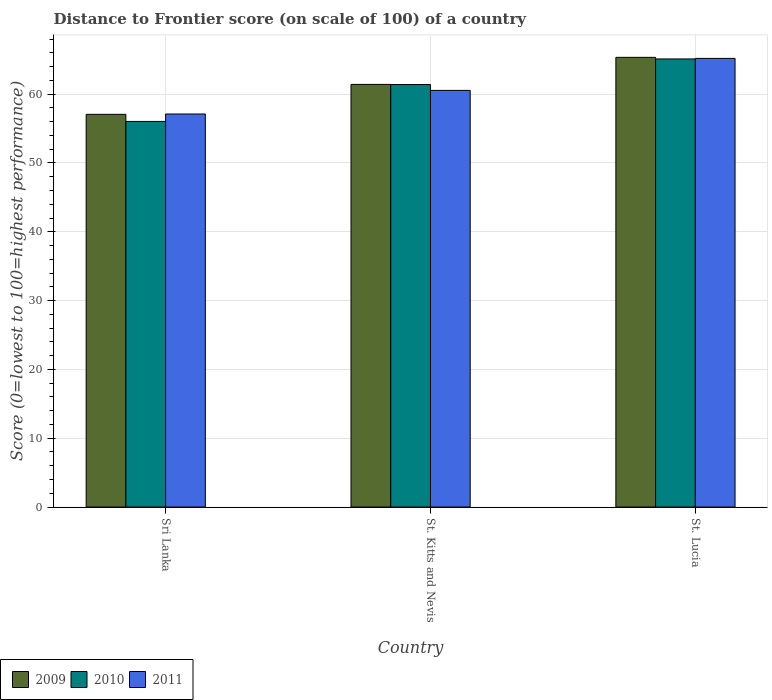How many groups of bars are there?
Provide a succinct answer. 3. Are the number of bars per tick equal to the number of legend labels?
Make the answer very short. Yes. Are the number of bars on each tick of the X-axis equal?
Offer a very short reply. Yes. How many bars are there on the 1st tick from the left?
Provide a short and direct response. 3. What is the label of the 1st group of bars from the left?
Your answer should be compact. Sri Lanka. In how many cases, is the number of bars for a given country not equal to the number of legend labels?
Offer a terse response. 0. What is the distance to frontier score of in 2011 in Sri Lanka?
Ensure brevity in your answer.  57.12. Across all countries, what is the maximum distance to frontier score of in 2011?
Offer a very short reply. 65.2. Across all countries, what is the minimum distance to frontier score of in 2011?
Provide a short and direct response. 57.12. In which country was the distance to frontier score of in 2009 maximum?
Your response must be concise. St. Lucia. In which country was the distance to frontier score of in 2009 minimum?
Offer a terse response. Sri Lanka. What is the total distance to frontier score of in 2010 in the graph?
Make the answer very short. 182.56. What is the difference between the distance to frontier score of in 2009 in Sri Lanka and that in St. Kitts and Nevis?
Your answer should be very brief. -4.35. What is the difference between the distance to frontier score of in 2010 in Sri Lanka and the distance to frontier score of in 2009 in St. Lucia?
Your answer should be very brief. -9.31. What is the average distance to frontier score of in 2010 per country?
Provide a short and direct response. 60.85. What is the difference between the distance to frontier score of of/in 2009 and distance to frontier score of of/in 2011 in St. Lucia?
Provide a short and direct response. 0.15. In how many countries, is the distance to frontier score of in 2011 greater than 32?
Give a very brief answer. 3. What is the ratio of the distance to frontier score of in 2010 in Sri Lanka to that in St. Kitts and Nevis?
Give a very brief answer. 0.91. Is the difference between the distance to frontier score of in 2009 in Sri Lanka and St. Lucia greater than the difference between the distance to frontier score of in 2011 in Sri Lanka and St. Lucia?
Keep it short and to the point. No. What is the difference between the highest and the second highest distance to frontier score of in 2011?
Provide a short and direct response. 4.65. What is the difference between the highest and the lowest distance to frontier score of in 2011?
Offer a terse response. 8.08. In how many countries, is the distance to frontier score of in 2010 greater than the average distance to frontier score of in 2010 taken over all countries?
Your response must be concise. 2. What does the 1st bar from the left in Sri Lanka represents?
Give a very brief answer. 2009. Is it the case that in every country, the sum of the distance to frontier score of in 2010 and distance to frontier score of in 2009 is greater than the distance to frontier score of in 2011?
Offer a terse response. Yes. Are all the bars in the graph horizontal?
Provide a succinct answer. No. What is the difference between two consecutive major ticks on the Y-axis?
Ensure brevity in your answer.  10. Does the graph contain any zero values?
Ensure brevity in your answer.  No. Does the graph contain grids?
Make the answer very short. Yes. Where does the legend appear in the graph?
Provide a succinct answer. Bottom left. How are the legend labels stacked?
Your answer should be compact. Horizontal. What is the title of the graph?
Ensure brevity in your answer.  Distance to Frontier score (on scale of 100) of a country. Does "2000" appear as one of the legend labels in the graph?
Your answer should be compact. No. What is the label or title of the X-axis?
Give a very brief answer. Country. What is the label or title of the Y-axis?
Offer a very short reply. Score (0=lowest to 100=highest performance). What is the Score (0=lowest to 100=highest performance) of 2009 in Sri Lanka?
Offer a very short reply. 57.07. What is the Score (0=lowest to 100=highest performance) of 2010 in Sri Lanka?
Keep it short and to the point. 56.04. What is the Score (0=lowest to 100=highest performance) of 2011 in Sri Lanka?
Provide a short and direct response. 57.12. What is the Score (0=lowest to 100=highest performance) of 2009 in St. Kitts and Nevis?
Your answer should be very brief. 61.42. What is the Score (0=lowest to 100=highest performance) of 2010 in St. Kitts and Nevis?
Offer a terse response. 61.4. What is the Score (0=lowest to 100=highest performance) in 2011 in St. Kitts and Nevis?
Provide a short and direct response. 60.55. What is the Score (0=lowest to 100=highest performance) of 2009 in St. Lucia?
Offer a terse response. 65.35. What is the Score (0=lowest to 100=highest performance) in 2010 in St. Lucia?
Give a very brief answer. 65.12. What is the Score (0=lowest to 100=highest performance) in 2011 in St. Lucia?
Give a very brief answer. 65.2. Across all countries, what is the maximum Score (0=lowest to 100=highest performance) in 2009?
Provide a succinct answer. 65.35. Across all countries, what is the maximum Score (0=lowest to 100=highest performance) in 2010?
Your answer should be compact. 65.12. Across all countries, what is the maximum Score (0=lowest to 100=highest performance) in 2011?
Your answer should be very brief. 65.2. Across all countries, what is the minimum Score (0=lowest to 100=highest performance) in 2009?
Ensure brevity in your answer.  57.07. Across all countries, what is the minimum Score (0=lowest to 100=highest performance) in 2010?
Make the answer very short. 56.04. Across all countries, what is the minimum Score (0=lowest to 100=highest performance) of 2011?
Offer a very short reply. 57.12. What is the total Score (0=lowest to 100=highest performance) of 2009 in the graph?
Make the answer very short. 183.84. What is the total Score (0=lowest to 100=highest performance) in 2010 in the graph?
Give a very brief answer. 182.56. What is the total Score (0=lowest to 100=highest performance) in 2011 in the graph?
Your response must be concise. 182.87. What is the difference between the Score (0=lowest to 100=highest performance) of 2009 in Sri Lanka and that in St. Kitts and Nevis?
Ensure brevity in your answer.  -4.35. What is the difference between the Score (0=lowest to 100=highest performance) in 2010 in Sri Lanka and that in St. Kitts and Nevis?
Your answer should be compact. -5.36. What is the difference between the Score (0=lowest to 100=highest performance) of 2011 in Sri Lanka and that in St. Kitts and Nevis?
Make the answer very short. -3.43. What is the difference between the Score (0=lowest to 100=highest performance) in 2009 in Sri Lanka and that in St. Lucia?
Ensure brevity in your answer.  -8.28. What is the difference between the Score (0=lowest to 100=highest performance) of 2010 in Sri Lanka and that in St. Lucia?
Offer a terse response. -9.08. What is the difference between the Score (0=lowest to 100=highest performance) of 2011 in Sri Lanka and that in St. Lucia?
Provide a short and direct response. -8.08. What is the difference between the Score (0=lowest to 100=highest performance) of 2009 in St. Kitts and Nevis and that in St. Lucia?
Your answer should be compact. -3.93. What is the difference between the Score (0=lowest to 100=highest performance) in 2010 in St. Kitts and Nevis and that in St. Lucia?
Offer a very short reply. -3.72. What is the difference between the Score (0=lowest to 100=highest performance) of 2011 in St. Kitts and Nevis and that in St. Lucia?
Give a very brief answer. -4.65. What is the difference between the Score (0=lowest to 100=highest performance) in 2009 in Sri Lanka and the Score (0=lowest to 100=highest performance) in 2010 in St. Kitts and Nevis?
Your answer should be compact. -4.33. What is the difference between the Score (0=lowest to 100=highest performance) of 2009 in Sri Lanka and the Score (0=lowest to 100=highest performance) of 2011 in St. Kitts and Nevis?
Ensure brevity in your answer.  -3.48. What is the difference between the Score (0=lowest to 100=highest performance) of 2010 in Sri Lanka and the Score (0=lowest to 100=highest performance) of 2011 in St. Kitts and Nevis?
Make the answer very short. -4.51. What is the difference between the Score (0=lowest to 100=highest performance) of 2009 in Sri Lanka and the Score (0=lowest to 100=highest performance) of 2010 in St. Lucia?
Your answer should be very brief. -8.05. What is the difference between the Score (0=lowest to 100=highest performance) of 2009 in Sri Lanka and the Score (0=lowest to 100=highest performance) of 2011 in St. Lucia?
Make the answer very short. -8.13. What is the difference between the Score (0=lowest to 100=highest performance) of 2010 in Sri Lanka and the Score (0=lowest to 100=highest performance) of 2011 in St. Lucia?
Your answer should be very brief. -9.16. What is the difference between the Score (0=lowest to 100=highest performance) in 2009 in St. Kitts and Nevis and the Score (0=lowest to 100=highest performance) in 2011 in St. Lucia?
Provide a short and direct response. -3.78. What is the difference between the Score (0=lowest to 100=highest performance) in 2010 in St. Kitts and Nevis and the Score (0=lowest to 100=highest performance) in 2011 in St. Lucia?
Your answer should be very brief. -3.8. What is the average Score (0=lowest to 100=highest performance) of 2009 per country?
Give a very brief answer. 61.28. What is the average Score (0=lowest to 100=highest performance) of 2010 per country?
Provide a short and direct response. 60.85. What is the average Score (0=lowest to 100=highest performance) of 2011 per country?
Give a very brief answer. 60.96. What is the difference between the Score (0=lowest to 100=highest performance) of 2009 and Score (0=lowest to 100=highest performance) of 2010 in Sri Lanka?
Your answer should be compact. 1.03. What is the difference between the Score (0=lowest to 100=highest performance) in 2010 and Score (0=lowest to 100=highest performance) in 2011 in Sri Lanka?
Give a very brief answer. -1.08. What is the difference between the Score (0=lowest to 100=highest performance) of 2009 and Score (0=lowest to 100=highest performance) of 2010 in St. Kitts and Nevis?
Give a very brief answer. 0.02. What is the difference between the Score (0=lowest to 100=highest performance) of 2009 and Score (0=lowest to 100=highest performance) of 2011 in St. Kitts and Nevis?
Your response must be concise. 0.87. What is the difference between the Score (0=lowest to 100=highest performance) in 2010 and Score (0=lowest to 100=highest performance) in 2011 in St. Kitts and Nevis?
Offer a very short reply. 0.85. What is the difference between the Score (0=lowest to 100=highest performance) in 2009 and Score (0=lowest to 100=highest performance) in 2010 in St. Lucia?
Offer a very short reply. 0.23. What is the difference between the Score (0=lowest to 100=highest performance) in 2009 and Score (0=lowest to 100=highest performance) in 2011 in St. Lucia?
Your response must be concise. 0.15. What is the difference between the Score (0=lowest to 100=highest performance) in 2010 and Score (0=lowest to 100=highest performance) in 2011 in St. Lucia?
Your answer should be very brief. -0.08. What is the ratio of the Score (0=lowest to 100=highest performance) in 2009 in Sri Lanka to that in St. Kitts and Nevis?
Offer a very short reply. 0.93. What is the ratio of the Score (0=lowest to 100=highest performance) in 2010 in Sri Lanka to that in St. Kitts and Nevis?
Keep it short and to the point. 0.91. What is the ratio of the Score (0=lowest to 100=highest performance) of 2011 in Sri Lanka to that in St. Kitts and Nevis?
Give a very brief answer. 0.94. What is the ratio of the Score (0=lowest to 100=highest performance) of 2009 in Sri Lanka to that in St. Lucia?
Provide a short and direct response. 0.87. What is the ratio of the Score (0=lowest to 100=highest performance) in 2010 in Sri Lanka to that in St. Lucia?
Keep it short and to the point. 0.86. What is the ratio of the Score (0=lowest to 100=highest performance) of 2011 in Sri Lanka to that in St. Lucia?
Provide a short and direct response. 0.88. What is the ratio of the Score (0=lowest to 100=highest performance) of 2009 in St. Kitts and Nevis to that in St. Lucia?
Give a very brief answer. 0.94. What is the ratio of the Score (0=lowest to 100=highest performance) in 2010 in St. Kitts and Nevis to that in St. Lucia?
Offer a terse response. 0.94. What is the ratio of the Score (0=lowest to 100=highest performance) of 2011 in St. Kitts and Nevis to that in St. Lucia?
Provide a short and direct response. 0.93. What is the difference between the highest and the second highest Score (0=lowest to 100=highest performance) in 2009?
Your response must be concise. 3.93. What is the difference between the highest and the second highest Score (0=lowest to 100=highest performance) in 2010?
Keep it short and to the point. 3.72. What is the difference between the highest and the second highest Score (0=lowest to 100=highest performance) of 2011?
Keep it short and to the point. 4.65. What is the difference between the highest and the lowest Score (0=lowest to 100=highest performance) in 2009?
Offer a very short reply. 8.28. What is the difference between the highest and the lowest Score (0=lowest to 100=highest performance) of 2010?
Provide a short and direct response. 9.08. What is the difference between the highest and the lowest Score (0=lowest to 100=highest performance) of 2011?
Keep it short and to the point. 8.08. 